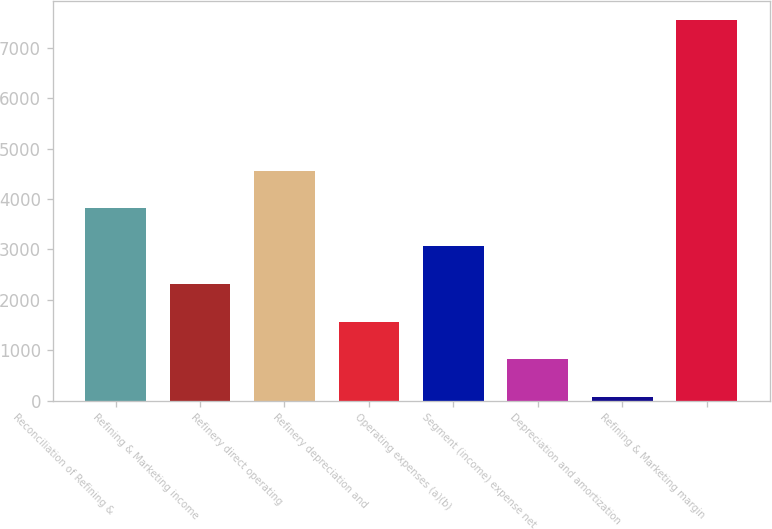<chart> <loc_0><loc_0><loc_500><loc_500><bar_chart><fcel>Reconciliation of Refining &<fcel>Refining & Marketing income<fcel>Refinery direct operating<fcel>Refinery depreciation and<fcel>Operating expenses (a)(b)<fcel>Segment (income) expense net<fcel>Depreciation and amortization<fcel>Refining & Marketing margin<nl><fcel>3813<fcel>2315.4<fcel>4561.8<fcel>1566.6<fcel>3064.2<fcel>817.8<fcel>69<fcel>7557<nl></chart> 